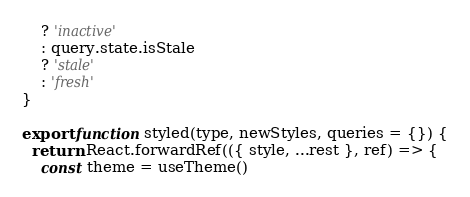Convert code to text. <code><loc_0><loc_0><loc_500><loc_500><_JavaScript_>    ? 'inactive'
    : query.state.isStale
    ? 'stale'
    : 'fresh'
}

export function styled(type, newStyles, queries = {}) {
  return React.forwardRef(({ style, ...rest }, ref) => {
    const theme = useTheme()
</code> 